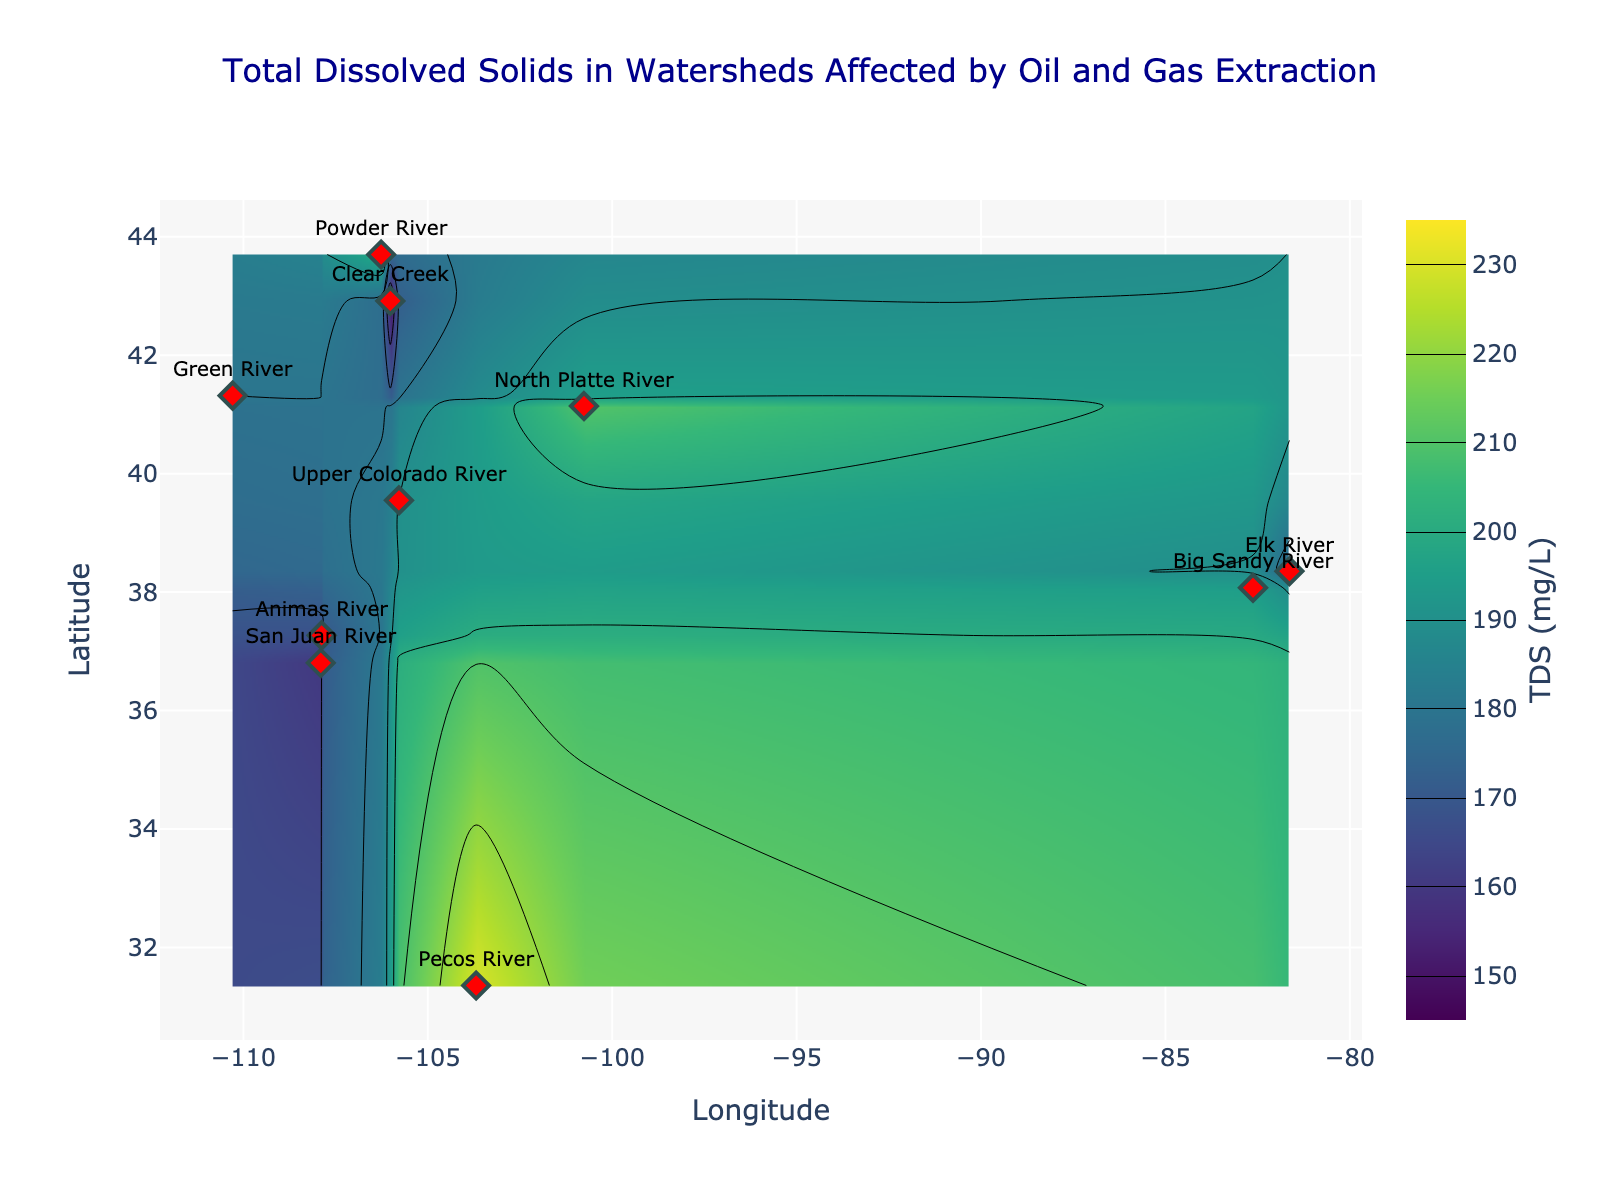What is the title of the figure? The title is shown at the top center of the figure, displayed prominently in DarkBlue color and a readable font size.
Answer: Total Dissolved Solids in Watersheds Affected by Oil and Gas Extraction How many watersheds are represented in the plot? Count the number of distinct markers labeled with watershed names on the scatter plot.
Answer: 10 Which watershed has the highest Total Dissolved Solids (TDS) value, and what is that value? Identify the maximum TDS value from the contour plot and match it to the corresponding watershed marked with text.
Answer: Pecos River, 230 mg/L What is the range of Total Dissolved Solids (TDS) values visualized in the plot? The color bar on the right side of the contour plot indicates the range of values visualized by the heatmap colors.
Answer: 150 to 230 mg/L Which watershed shows the lowest TDS value, and what is the value? Find the minimum TDS value from the contour plot and identify the label corresponding to that value.
Answer: Clear Creek, 150 mg/L How are watersheds represented visually on the plot? Observe the markers and text annotations used in the scatter plot overlay on the contour map.
Answer: Red diamond markers with watershed names in text Compare the TDS values between the Upper Colorado River and the Powder River. Which one is higher? Locate both watersheds on the contour plot and compare their corresponding TDS values.
Answer: Powder River is higher What is the general trend in TDS levels relative to the latitude? Observe the distribution of color gradients and compare the changes in TDS levels along the y-axis (latitude).
Answer: Higher TDS levels are generally observed at lower latitudes Are there any regions with TDS values around 180 mg/L? Identify the color range representing 180 mg/L on the color bar and find regions with that color in the contour plot.
Answer: Yes, around Green River and Animas River Which watershed appears to have a significant increase in TDS compared to its immediate surroundings? Identify any sharp gradients in the contour plot around specific watersheds and compare them to their neighboring points.
Answer: Pecos River 